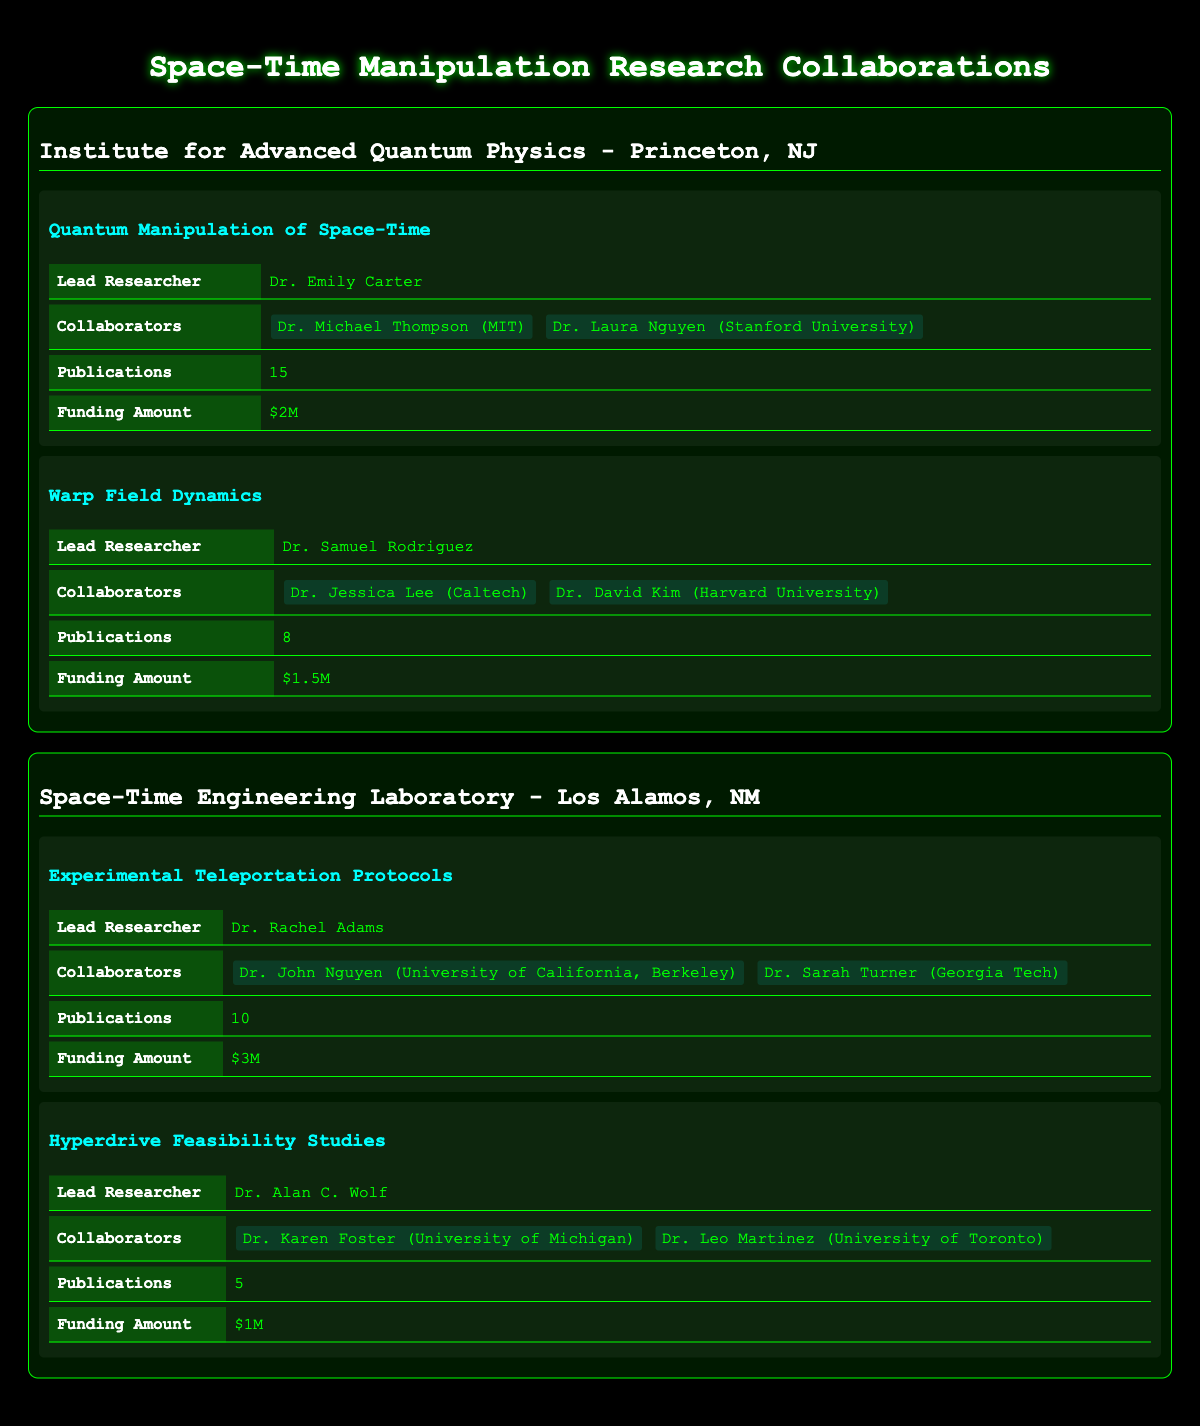What is the location of the Institute for Advanced Quantum Physics? The table states that the Institute for Advanced Quantum Physics is located in Princeton, NJ.
Answer: Princeton, NJ Who is the lead researcher for the project "Experimental Teleportation Protocols"? According to the table, Dr. Rachel Adams is the lead researcher for the project "Experimental Teleportation Protocols."
Answer: Dr. Rachel Adams How many publications were made in total by the projects at the Space-Time Engineering Laboratory? The Space-Time Engineering Laboratory has two projects: "Experimental Teleportation Protocols" with 10 publications and "Hyperdrive Feasibility Studies" with 5 publications. The total is 10 + 5 = 15 publications.
Answer: 15 Is the total funding amount for the "Warp Field Dynamics" project greater than $1M? The table shows that the funding for "Warp Field Dynamics" is $1.5M, which is greater than $1M. Thus, the statement is true.
Answer: Yes Which research group has the highest total funding amount from all of its projects combined? The Institute for Advanced Quantum Physics has funding amounts of $2M for "Quantum Manipulation of Space-Time" and $1.5M for "Warp Field Dynamics," totaling $3.5M. The Space-Time Engineering Laboratory has $3M for "Experimental Teleportation Protocols" and $1M for "Hyperdrive Feasibility Studies," totaling $4M. Therefore, the Space-Time Engineering Laboratory has the highest total funding.
Answer: Space-Time Engineering Laboratory What are the names and affiliations of the collaborators on the project "Warp Field Dynamics"? The table lists Dr. Jessica Lee from Caltech and Dr. David Kim from Harvard University as collaborators on "Warp Field Dynamics."
Answer: Dr. Jessica Lee (Caltech) and Dr. David Kim (Harvard University) Is there a project at the Institute for Advanced Quantum Physics that has both more publications and less funding than any of the projects at the Space-Time Engineering Laboratory? The Quantum Manipulation of Space-Time project has 15 publications and $2M funding, while the Hyperdrive Feasibility Studies project has 5 publications and $1M funding. Since there are no projects from the Institute with more publications and less funding than the projects from the Space-Time Engineering Laboratory, this statement is false.
Answer: No What is the average number of publications across all projects listed? The total number of publications across all projects is 15 + 8 + 10 + 5 = 38. There are four projects, so the average number of publications is 38 divided by 4, which equals 9.5.
Answer: 9.5 